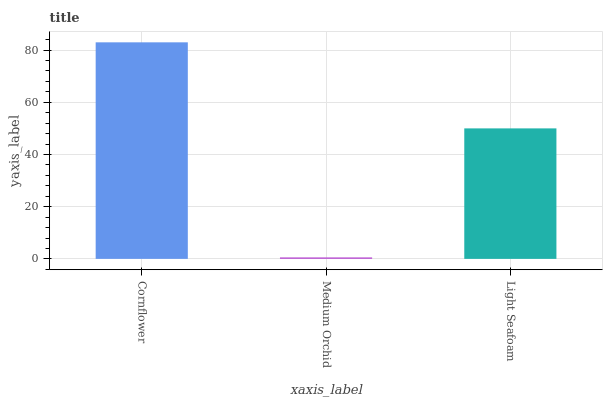Is Medium Orchid the minimum?
Answer yes or no. Yes. Is Cornflower the maximum?
Answer yes or no. Yes. Is Light Seafoam the minimum?
Answer yes or no. No. Is Light Seafoam the maximum?
Answer yes or no. No. Is Light Seafoam greater than Medium Orchid?
Answer yes or no. Yes. Is Medium Orchid less than Light Seafoam?
Answer yes or no. Yes. Is Medium Orchid greater than Light Seafoam?
Answer yes or no. No. Is Light Seafoam less than Medium Orchid?
Answer yes or no. No. Is Light Seafoam the high median?
Answer yes or no. Yes. Is Light Seafoam the low median?
Answer yes or no. Yes. Is Medium Orchid the high median?
Answer yes or no. No. Is Medium Orchid the low median?
Answer yes or no. No. 